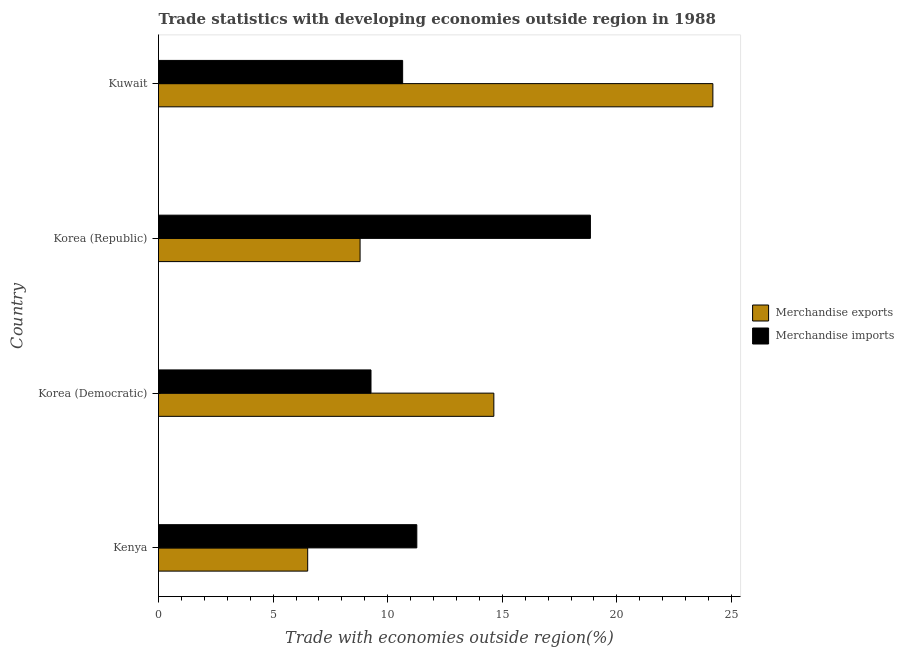How many groups of bars are there?
Provide a succinct answer. 4. Are the number of bars per tick equal to the number of legend labels?
Make the answer very short. Yes. Are the number of bars on each tick of the Y-axis equal?
Your answer should be compact. Yes. How many bars are there on the 1st tick from the bottom?
Provide a short and direct response. 2. What is the label of the 3rd group of bars from the top?
Your answer should be very brief. Korea (Democratic). What is the merchandise exports in Korea (Republic)?
Your response must be concise. 8.8. Across all countries, what is the maximum merchandise imports?
Offer a very short reply. 18.85. Across all countries, what is the minimum merchandise exports?
Keep it short and to the point. 6.51. In which country was the merchandise exports maximum?
Ensure brevity in your answer.  Kuwait. In which country was the merchandise imports minimum?
Your response must be concise. Korea (Democratic). What is the total merchandise imports in the graph?
Offer a very short reply. 50.04. What is the difference between the merchandise exports in Korea (Republic) and that in Kuwait?
Your answer should be compact. -15.39. What is the difference between the merchandise exports in Kuwait and the merchandise imports in Korea (Democratic)?
Provide a short and direct response. 14.92. What is the average merchandise imports per country?
Offer a terse response. 12.51. What is the difference between the merchandise imports and merchandise exports in Kuwait?
Your response must be concise. -13.54. In how many countries, is the merchandise exports greater than 4 %?
Your answer should be compact. 4. What is the ratio of the merchandise exports in Kenya to that in Korea (Democratic)?
Make the answer very short. 0.45. What is the difference between the highest and the second highest merchandise imports?
Offer a terse response. 7.58. What is the difference between the highest and the lowest merchandise exports?
Keep it short and to the point. 17.68. Is the sum of the merchandise exports in Korea (Democratic) and Korea (Republic) greater than the maximum merchandise imports across all countries?
Provide a succinct answer. Yes. What does the 2nd bar from the top in Kenya represents?
Offer a very short reply. Merchandise exports. How many countries are there in the graph?
Keep it short and to the point. 4. Are the values on the major ticks of X-axis written in scientific E-notation?
Your response must be concise. No. Does the graph contain any zero values?
Offer a terse response. No. Where does the legend appear in the graph?
Provide a succinct answer. Center right. How many legend labels are there?
Your response must be concise. 2. How are the legend labels stacked?
Ensure brevity in your answer.  Vertical. What is the title of the graph?
Provide a succinct answer. Trade statistics with developing economies outside region in 1988. What is the label or title of the X-axis?
Ensure brevity in your answer.  Trade with economies outside region(%). What is the label or title of the Y-axis?
Ensure brevity in your answer.  Country. What is the Trade with economies outside region(%) of Merchandise exports in Kenya?
Offer a terse response. 6.51. What is the Trade with economies outside region(%) in Merchandise imports in Kenya?
Give a very brief answer. 11.27. What is the Trade with economies outside region(%) in Merchandise exports in Korea (Democratic)?
Provide a short and direct response. 14.63. What is the Trade with economies outside region(%) of Merchandise imports in Korea (Democratic)?
Provide a succinct answer. 9.27. What is the Trade with economies outside region(%) of Merchandise exports in Korea (Republic)?
Your answer should be very brief. 8.8. What is the Trade with economies outside region(%) in Merchandise imports in Korea (Republic)?
Provide a short and direct response. 18.85. What is the Trade with economies outside region(%) of Merchandise exports in Kuwait?
Make the answer very short. 24.19. What is the Trade with economies outside region(%) in Merchandise imports in Kuwait?
Offer a very short reply. 10.65. Across all countries, what is the maximum Trade with economies outside region(%) in Merchandise exports?
Keep it short and to the point. 24.19. Across all countries, what is the maximum Trade with economies outside region(%) of Merchandise imports?
Offer a terse response. 18.85. Across all countries, what is the minimum Trade with economies outside region(%) of Merchandise exports?
Offer a terse response. 6.51. Across all countries, what is the minimum Trade with economies outside region(%) of Merchandise imports?
Ensure brevity in your answer.  9.27. What is the total Trade with economies outside region(%) of Merchandise exports in the graph?
Ensure brevity in your answer.  54.13. What is the total Trade with economies outside region(%) in Merchandise imports in the graph?
Your response must be concise. 50.04. What is the difference between the Trade with economies outside region(%) in Merchandise exports in Kenya and that in Korea (Democratic)?
Offer a very short reply. -8.12. What is the difference between the Trade with economies outside region(%) in Merchandise imports in Kenya and that in Korea (Democratic)?
Give a very brief answer. 2. What is the difference between the Trade with economies outside region(%) of Merchandise exports in Kenya and that in Korea (Republic)?
Ensure brevity in your answer.  -2.29. What is the difference between the Trade with economies outside region(%) of Merchandise imports in Kenya and that in Korea (Republic)?
Ensure brevity in your answer.  -7.58. What is the difference between the Trade with economies outside region(%) in Merchandise exports in Kenya and that in Kuwait?
Offer a very short reply. -17.68. What is the difference between the Trade with economies outside region(%) in Merchandise imports in Kenya and that in Kuwait?
Your response must be concise. 0.62. What is the difference between the Trade with economies outside region(%) of Merchandise exports in Korea (Democratic) and that in Korea (Republic)?
Keep it short and to the point. 5.84. What is the difference between the Trade with economies outside region(%) in Merchandise imports in Korea (Democratic) and that in Korea (Republic)?
Your answer should be very brief. -9.57. What is the difference between the Trade with economies outside region(%) of Merchandise exports in Korea (Democratic) and that in Kuwait?
Your response must be concise. -9.56. What is the difference between the Trade with economies outside region(%) of Merchandise imports in Korea (Democratic) and that in Kuwait?
Provide a short and direct response. -1.38. What is the difference between the Trade with economies outside region(%) of Merchandise exports in Korea (Republic) and that in Kuwait?
Ensure brevity in your answer.  -15.39. What is the difference between the Trade with economies outside region(%) in Merchandise imports in Korea (Republic) and that in Kuwait?
Provide a short and direct response. 8.19. What is the difference between the Trade with economies outside region(%) in Merchandise exports in Kenya and the Trade with economies outside region(%) in Merchandise imports in Korea (Democratic)?
Offer a terse response. -2.76. What is the difference between the Trade with economies outside region(%) of Merchandise exports in Kenya and the Trade with economies outside region(%) of Merchandise imports in Korea (Republic)?
Your response must be concise. -12.34. What is the difference between the Trade with economies outside region(%) in Merchandise exports in Kenya and the Trade with economies outside region(%) in Merchandise imports in Kuwait?
Your answer should be compact. -4.14. What is the difference between the Trade with economies outside region(%) in Merchandise exports in Korea (Democratic) and the Trade with economies outside region(%) in Merchandise imports in Korea (Republic)?
Your answer should be very brief. -4.21. What is the difference between the Trade with economies outside region(%) in Merchandise exports in Korea (Democratic) and the Trade with economies outside region(%) in Merchandise imports in Kuwait?
Ensure brevity in your answer.  3.98. What is the difference between the Trade with economies outside region(%) of Merchandise exports in Korea (Republic) and the Trade with economies outside region(%) of Merchandise imports in Kuwait?
Provide a succinct answer. -1.86. What is the average Trade with economies outside region(%) of Merchandise exports per country?
Offer a terse response. 13.53. What is the average Trade with economies outside region(%) of Merchandise imports per country?
Keep it short and to the point. 12.51. What is the difference between the Trade with economies outside region(%) in Merchandise exports and Trade with economies outside region(%) in Merchandise imports in Kenya?
Provide a short and direct response. -4.76. What is the difference between the Trade with economies outside region(%) in Merchandise exports and Trade with economies outside region(%) in Merchandise imports in Korea (Democratic)?
Ensure brevity in your answer.  5.36. What is the difference between the Trade with economies outside region(%) in Merchandise exports and Trade with economies outside region(%) in Merchandise imports in Korea (Republic)?
Your response must be concise. -10.05. What is the difference between the Trade with economies outside region(%) in Merchandise exports and Trade with economies outside region(%) in Merchandise imports in Kuwait?
Give a very brief answer. 13.54. What is the ratio of the Trade with economies outside region(%) of Merchandise exports in Kenya to that in Korea (Democratic)?
Provide a succinct answer. 0.44. What is the ratio of the Trade with economies outside region(%) of Merchandise imports in Kenya to that in Korea (Democratic)?
Your answer should be very brief. 1.22. What is the ratio of the Trade with economies outside region(%) of Merchandise exports in Kenya to that in Korea (Republic)?
Offer a very short reply. 0.74. What is the ratio of the Trade with economies outside region(%) in Merchandise imports in Kenya to that in Korea (Republic)?
Make the answer very short. 0.6. What is the ratio of the Trade with economies outside region(%) in Merchandise exports in Kenya to that in Kuwait?
Offer a very short reply. 0.27. What is the ratio of the Trade with economies outside region(%) in Merchandise imports in Kenya to that in Kuwait?
Offer a terse response. 1.06. What is the ratio of the Trade with economies outside region(%) in Merchandise exports in Korea (Democratic) to that in Korea (Republic)?
Your response must be concise. 1.66. What is the ratio of the Trade with economies outside region(%) of Merchandise imports in Korea (Democratic) to that in Korea (Republic)?
Ensure brevity in your answer.  0.49. What is the ratio of the Trade with economies outside region(%) in Merchandise exports in Korea (Democratic) to that in Kuwait?
Offer a terse response. 0.6. What is the ratio of the Trade with economies outside region(%) of Merchandise imports in Korea (Democratic) to that in Kuwait?
Keep it short and to the point. 0.87. What is the ratio of the Trade with economies outside region(%) in Merchandise exports in Korea (Republic) to that in Kuwait?
Your response must be concise. 0.36. What is the ratio of the Trade with economies outside region(%) of Merchandise imports in Korea (Republic) to that in Kuwait?
Give a very brief answer. 1.77. What is the difference between the highest and the second highest Trade with economies outside region(%) of Merchandise exports?
Keep it short and to the point. 9.56. What is the difference between the highest and the second highest Trade with economies outside region(%) in Merchandise imports?
Ensure brevity in your answer.  7.58. What is the difference between the highest and the lowest Trade with economies outside region(%) in Merchandise exports?
Offer a terse response. 17.68. What is the difference between the highest and the lowest Trade with economies outside region(%) in Merchandise imports?
Offer a very short reply. 9.57. 